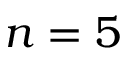Convert formula to latex. <formula><loc_0><loc_0><loc_500><loc_500>n = 5</formula> 